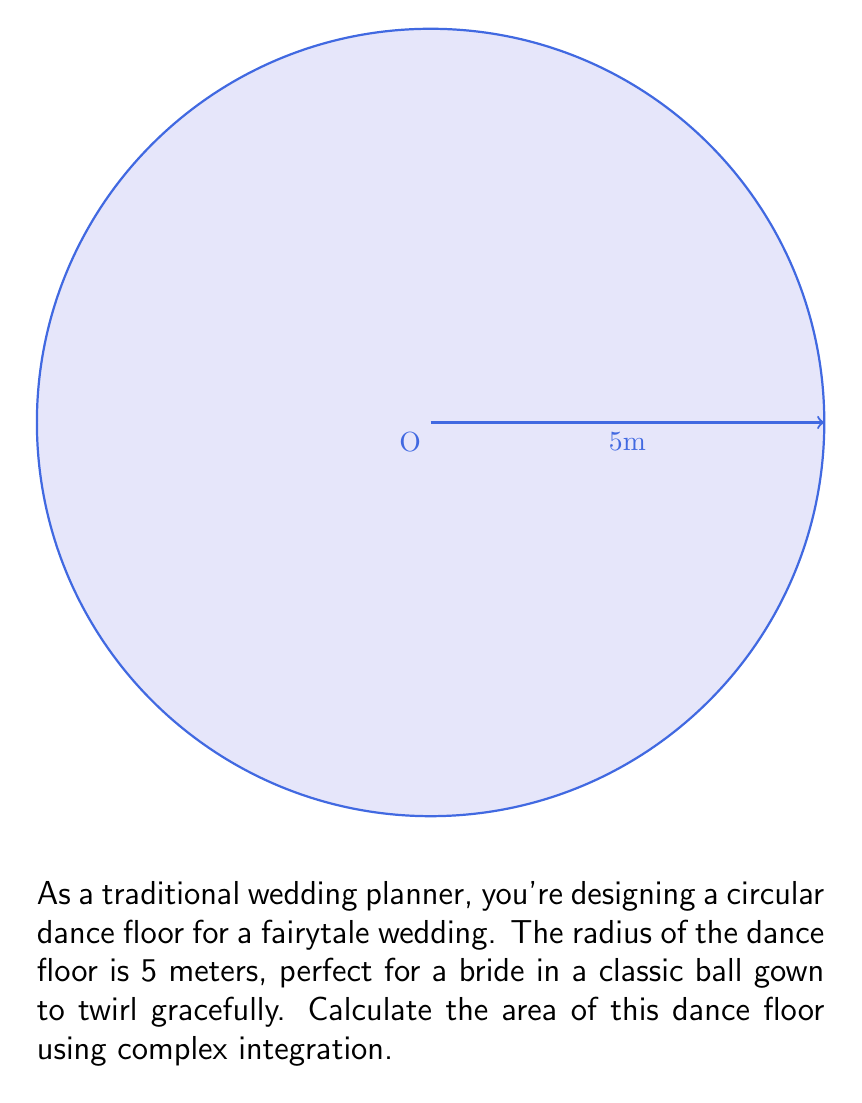What is the answer to this math problem? To calculate the area of the circular dance floor using complex integration, we'll follow these steps:

1) In complex analysis, we can represent a point on the circle as $z = re^{i\theta}$, where $r$ is the radius and $\theta$ is the angle.

2) The area of a region in the complex plane can be calculated using the formula:

   $$A = -\frac{1}{2i} \oint_C \bar{z}dz$$

   where $C$ is the boundary of the region, and $\bar{z}$ is the complex conjugate of $z$.

3) For our circle, $z = 5e^{i\theta}$ and $\bar{z} = 5e^{-i\theta}$

4) We need to find $dz$:
   $$dz = 5ie^{i\theta}d\theta$$

5) Substituting into our integral:

   $$A = -\frac{1}{2i} \int_0^{2\pi} 5e^{-i\theta} \cdot 5ie^{i\theta}d\theta$$

6) Simplify:

   $$A = -\frac{25}{2} \int_0^{2\pi} d\theta$$

7) Evaluate the integral:

   $$A = -\frac{25}{2} [θ]_0^{2π} = -\frac{25}{2} (2π - 0) = 25π$$

Therefore, the area of the circular dance floor is $25π$ square meters.
Answer: $25π$ m² 